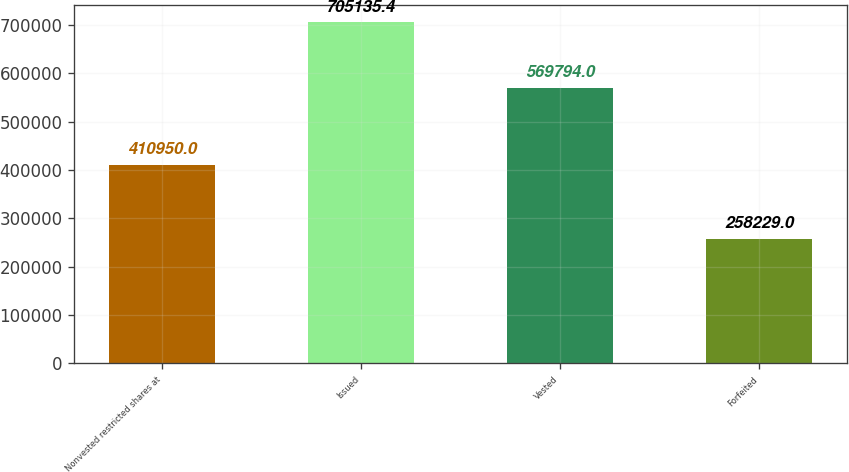Convert chart. <chart><loc_0><loc_0><loc_500><loc_500><bar_chart><fcel>Nonvested restricted shares at<fcel>Issued<fcel>Vested<fcel>Forfeited<nl><fcel>410950<fcel>705135<fcel>569794<fcel>258229<nl></chart> 